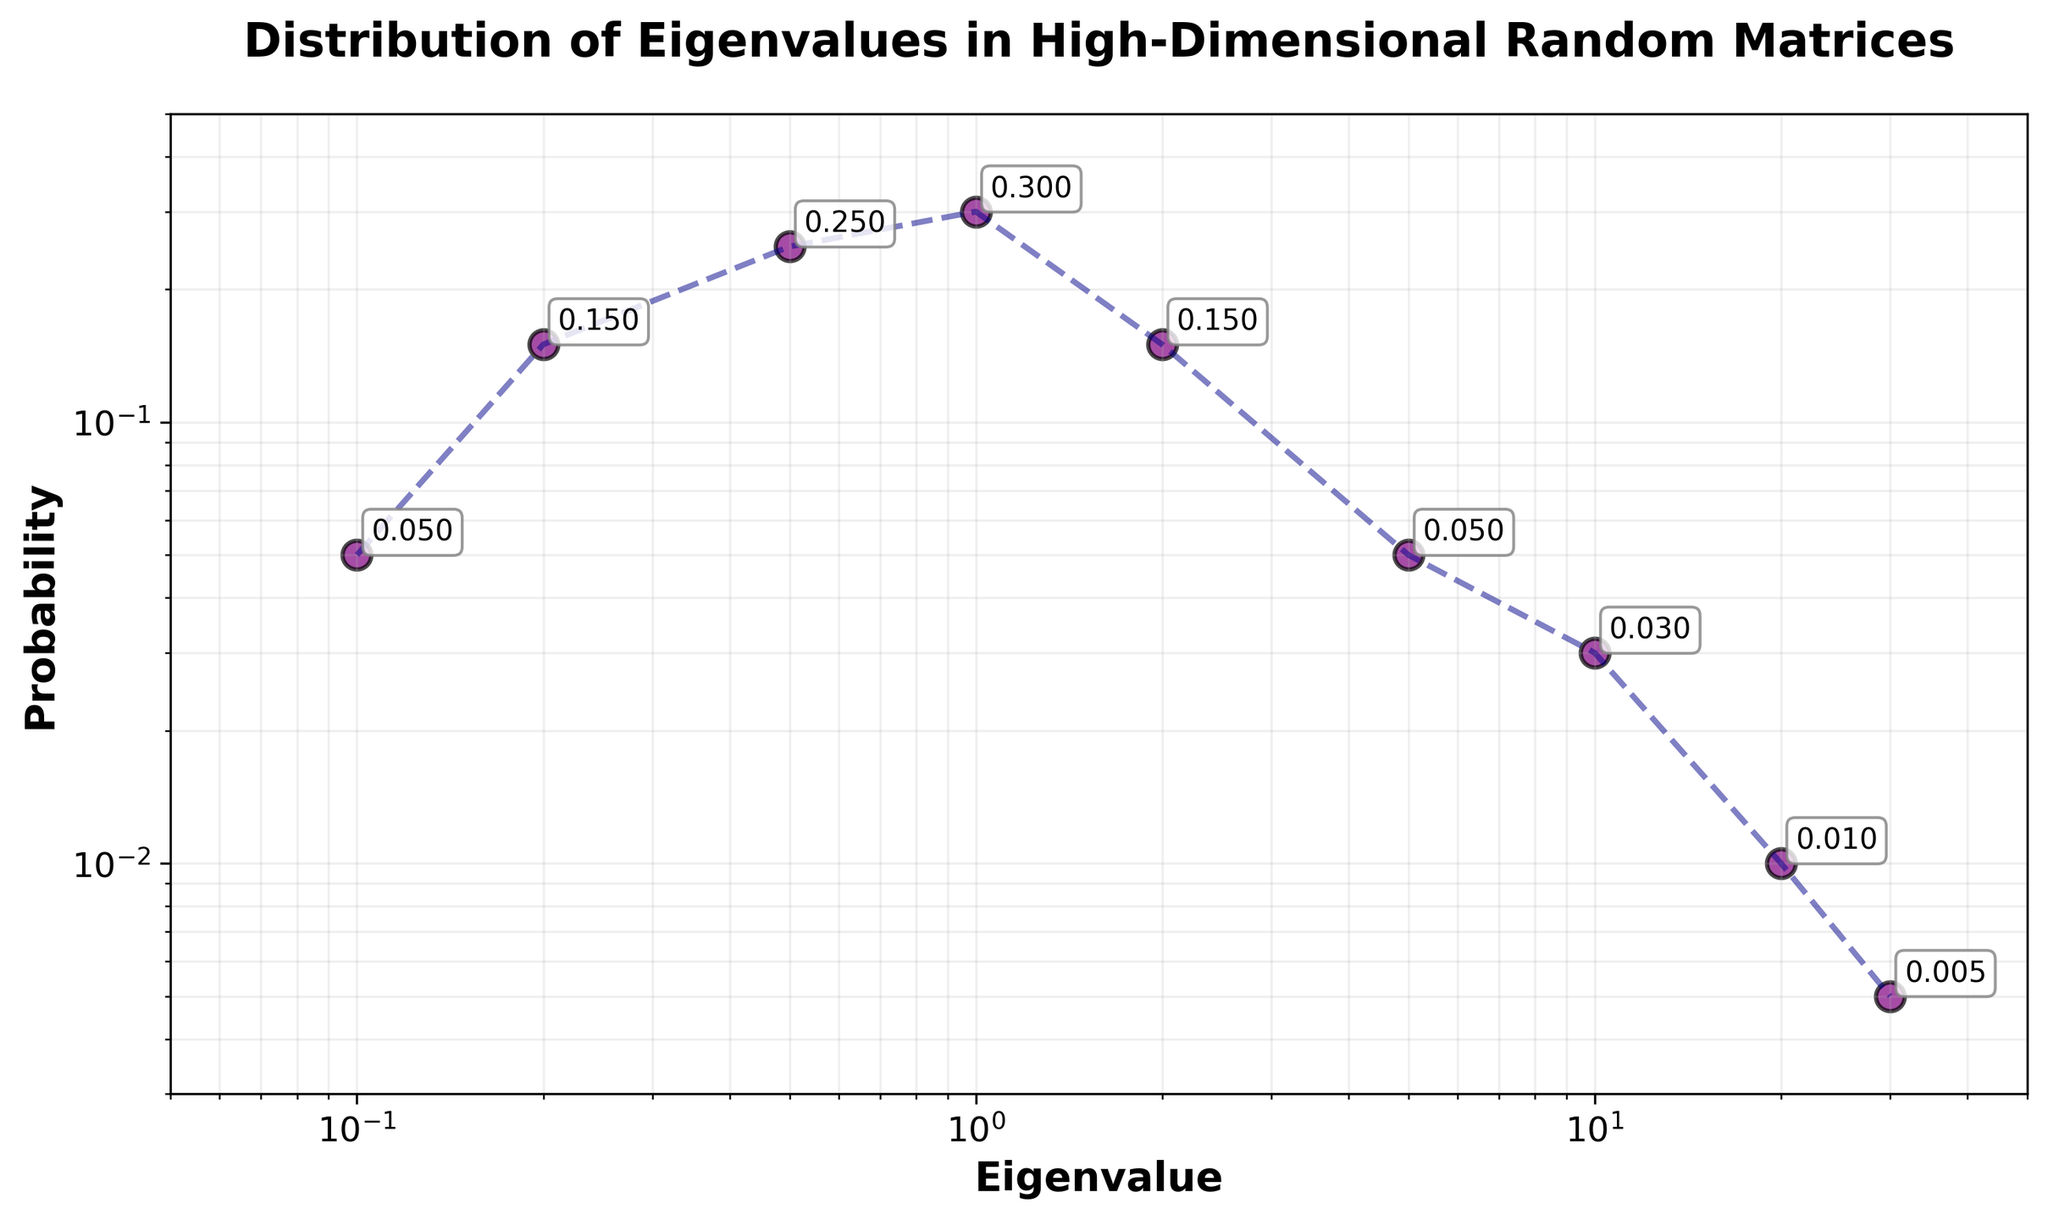What is the title of the plot? The title of the plot is displayed at the top center of the figure. It is "Distribution of Eigenvalues in High-Dimensional Random Matrices".
Answer: Distribution of Eigenvalues in High-Dimensional Random Matrices What are the labels of the x and y axes? The labels of the axes are found along the axes lines. For the x-axis, it is "Eigenvalue", and for the y-axis, it is "Probability".
Answer: Eigenvalue, Probability How many data points are plotted in the figure? Each point in the scatter plot represents one data point. By counting these points, we can determine there are 9 data points plotted in the figure.
Answer: 9 What is the probability value corresponding to the eigenvalue of 1? By finding the eigenvalue of 1 on the x-axis, we can trace it up to its corresponding probability on the y-axis, which is annotated near the data point. The value is 0.30.
Answer: 0.30 What is the color and shape of the data points? The data points are visualized as small circles (scatter points) in the plot. The color of these scatter points is purple with a black edge outline.
Answer: Purple circles with black edges What is the log scale representation range for the x-axis? The x-axis in log scale is ranged from 0.05 to 50 as set in the plot limits. This range is used for visualizing the eigenvalues.
Answer: 0.05 to 50 Which eigenvalue corresponds to the highest probability, and what is that probability? By examining the data points' y-values, the highest probability is found by observing the highest point on the y-axis. This corresponds to the eigenvalue of 1, with a probability of 0.30.
Answer: Eigenvalue: 1, Probability: 0.30 What is the combined probability of eigenvalues greater than or equal to 10? We sum the probabilities for eigenvalues 10, 20, and 30. The values are 0.03, 0.01, and 0.005 respectively. 0.03 + 0.01 + 0.005 = 0.045
Answer: 0.045 Which eigenvalue has the smallest probability, and what is that probability? The smallest probability value can be found by locating the smallest y-value. This corresponds to the eigenvalue of 30, with a probability of 0.005.
Answer: Eigenvalue: 30, Probability: 0.005 How does the probability change as the eigenvalue increases from 0.1 to 1? From the eigenvalue of 0.1 to 1, we observe the scatter plot and see that the probability increases initially (0.05 to 0.15 to 0.25 to 0.30). The probability thus increases consistently within this interval.
Answer: Increases 